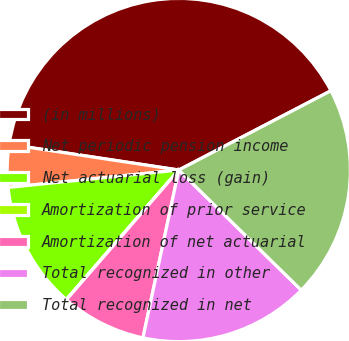Convert chart to OTSL. <chart><loc_0><loc_0><loc_500><loc_500><pie_chart><fcel>(in millions)<fcel>Net periodic pension income<fcel>Net actuarial loss (gain)<fcel>Amortization of prior service<fcel>Amortization of net actuarial<fcel>Total recognized in other<fcel>Total recognized in net<nl><fcel>39.96%<fcel>4.01%<fcel>12.0%<fcel>0.02%<fcel>8.01%<fcel>16.0%<fcel>19.99%<nl></chart> 